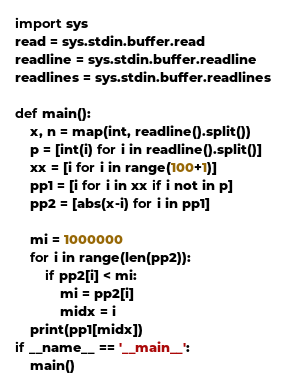<code> <loc_0><loc_0><loc_500><loc_500><_Python_>import sys
read = sys.stdin.buffer.read
readline = sys.stdin.buffer.readline
readlines = sys.stdin.buffer.readlines
 
def main():
    x, n = map(int, readline().split())
    p = [int(i) for i in readline().split()]
    xx = [i for i in range(100+1)]
    pp1 = [i for i in xx if i not in p] 
    pp2 = [abs(x-i) for i in pp1]

    mi = 1000000
    for i in range(len(pp2)):
        if pp2[i] < mi:
            mi = pp2[i]
            midx = i 
    print(pp1[midx])
if __name__ == '__main__':
    main()
</code> 